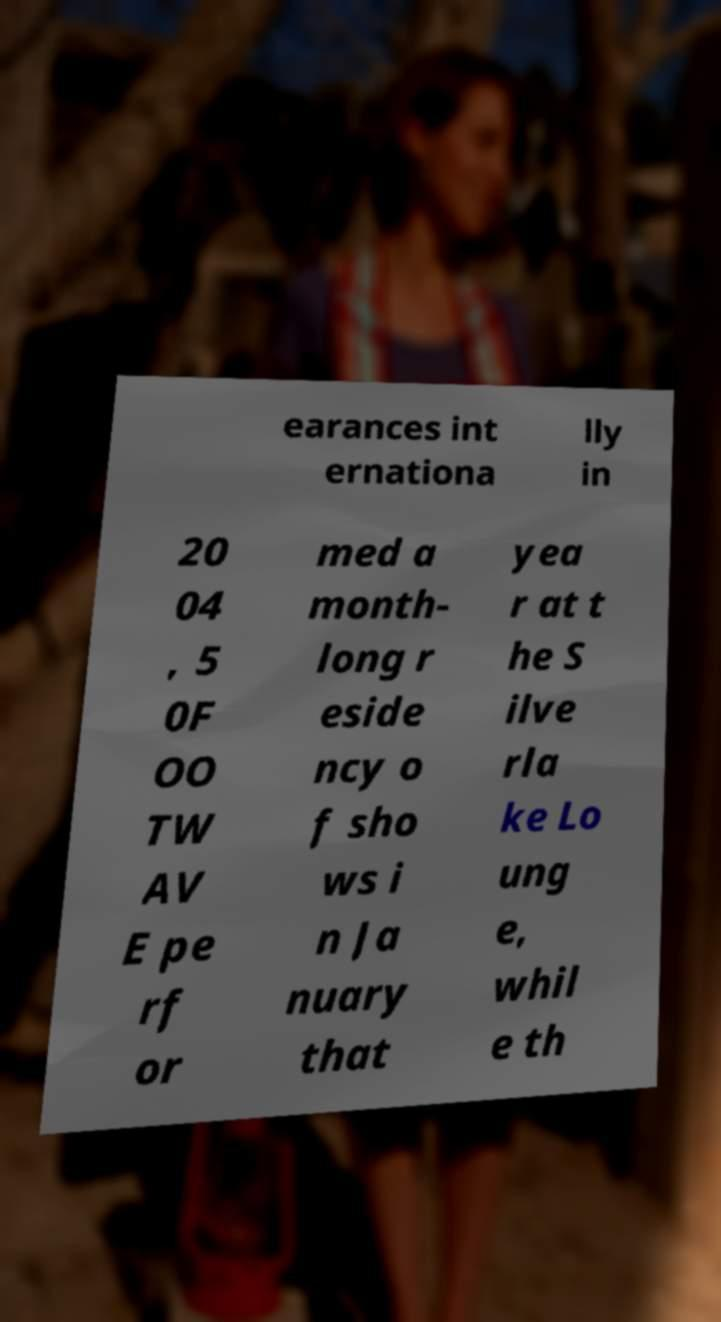Please read and relay the text visible in this image. What does it say? earances int ernationa lly in 20 04 , 5 0F OO TW AV E pe rf or med a month- long r eside ncy o f sho ws i n Ja nuary that yea r at t he S ilve rla ke Lo ung e, whil e th 